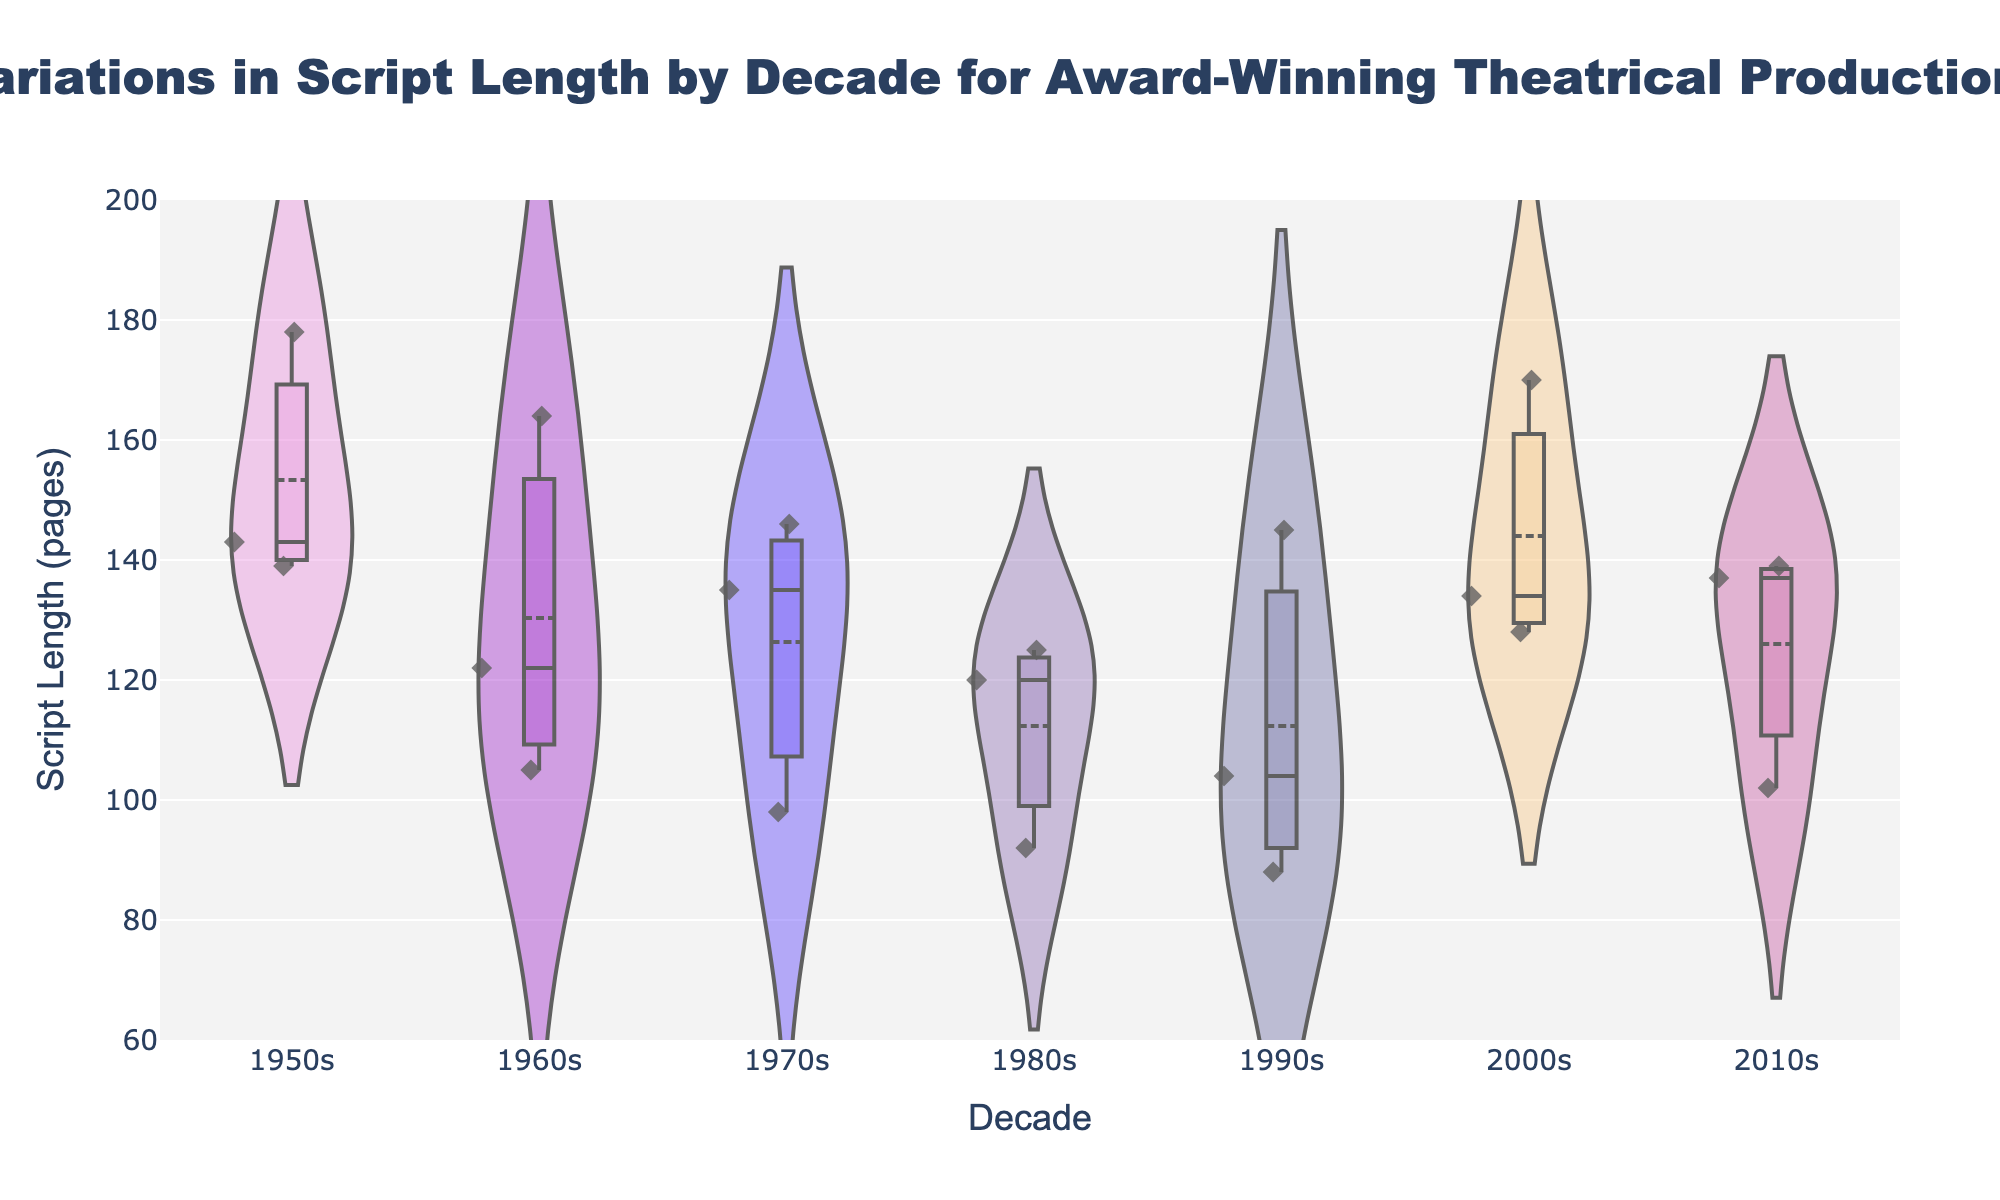How many decades are represented in the figure? Count the number of distinct labels along the x-axis representing different decades.
Answer: 6 What is the title of the figure? Read the text at the top of the figure that describes what the plot represents.
Answer: Variations in Script Length by Decade for Award-Winning Theatrical Productions What is the minimum script length in the 2010s? Examine the lowest point on the violin plot for the 2010s decade.
Answer: 102 pages Which decade has the widest range of script lengths? Compare the ranges of script lengths (from the lowest to the highest point) in the violin plots of each decade.
Answer: 2000s What is the median script length in the 1950s? Look for the central line in the violin plot for the 1950s and identify its value.
Answer: 143 pages How does the average script length in the 1970s compare to the average script length in the 1980s? Compare the mean lines in the violin plots for the 1970s and the 1980s.
Answer: Longer in the 1970s Which decade has the most consistent script lengths? Identify the decade with the narrowest violin plot, indicating less variation in script lengths.
Answer: 2010s What is the maximum script length in the 1990s? Examine the highest point on the violin plot for the 1990s to determine the maximum script length.
Answer: 145 pages Are there any outliers in the script lengths for the 1960s? Look for any points in the 1960s violin plot that are significantly outside the main distribution area.
Answer: No How many plays have a script length above 150 pages in the 2000s? Count the number of data points above the 150 pages mark in the violin plot for the 2000s.
Answer: 1 